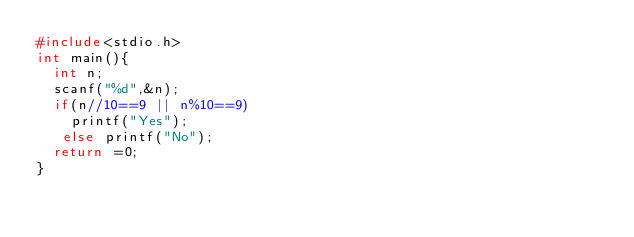<code> <loc_0><loc_0><loc_500><loc_500><_C_>#include<stdio.h>
int main(){
  int n;
  scanf("%d",&n);
  if(n//10==9 || n%10==9)
    printf("Yes");
   else printf("No");
  return =0;
}</code> 